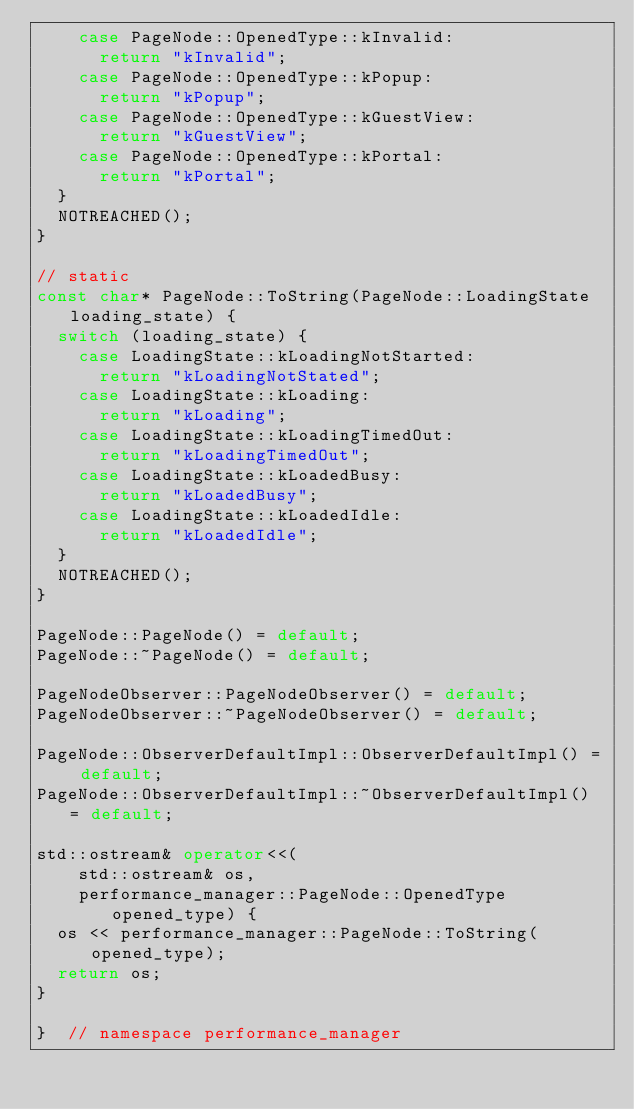<code> <loc_0><loc_0><loc_500><loc_500><_C++_>    case PageNode::OpenedType::kInvalid:
      return "kInvalid";
    case PageNode::OpenedType::kPopup:
      return "kPopup";
    case PageNode::OpenedType::kGuestView:
      return "kGuestView";
    case PageNode::OpenedType::kPortal:
      return "kPortal";
  }
  NOTREACHED();
}

// static
const char* PageNode::ToString(PageNode::LoadingState loading_state) {
  switch (loading_state) {
    case LoadingState::kLoadingNotStarted:
      return "kLoadingNotStated";
    case LoadingState::kLoading:
      return "kLoading";
    case LoadingState::kLoadingTimedOut:
      return "kLoadingTimedOut";
    case LoadingState::kLoadedBusy:
      return "kLoadedBusy";
    case LoadingState::kLoadedIdle:
      return "kLoadedIdle";
  }
  NOTREACHED();
}

PageNode::PageNode() = default;
PageNode::~PageNode() = default;

PageNodeObserver::PageNodeObserver() = default;
PageNodeObserver::~PageNodeObserver() = default;

PageNode::ObserverDefaultImpl::ObserverDefaultImpl() = default;
PageNode::ObserverDefaultImpl::~ObserverDefaultImpl() = default;

std::ostream& operator<<(
    std::ostream& os,
    performance_manager::PageNode::OpenedType opened_type) {
  os << performance_manager::PageNode::ToString(opened_type);
  return os;
}

}  // namespace performance_manager
</code> 